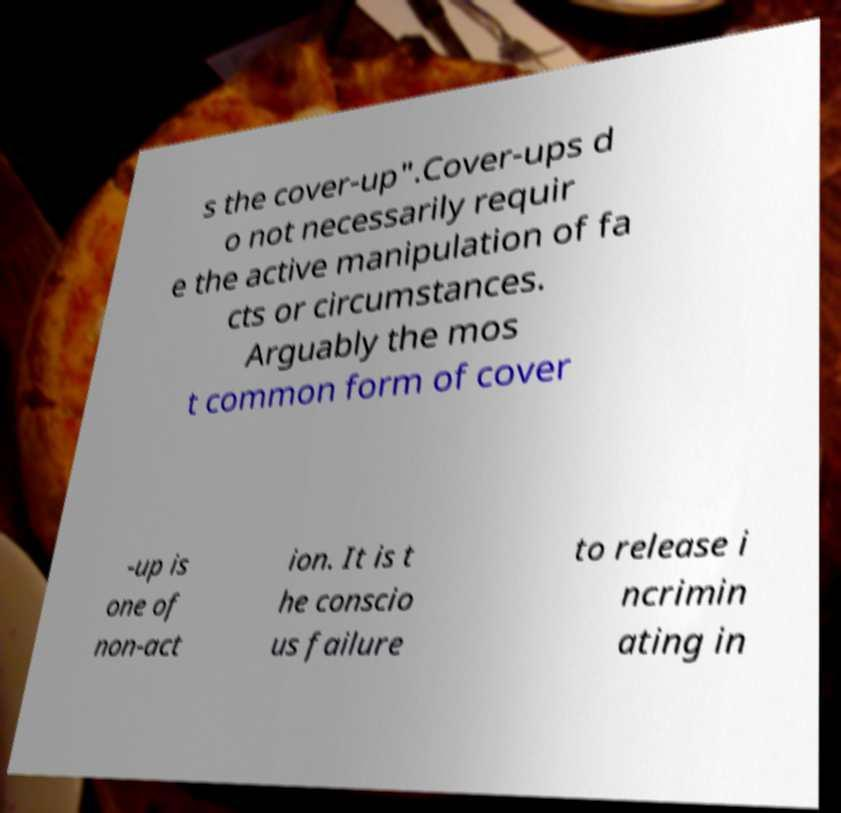Please read and relay the text visible in this image. What does it say? s the cover-up".Cover-ups d o not necessarily requir e the active manipulation of fa cts or circumstances. Arguably the mos t common form of cover -up is one of non-act ion. It is t he conscio us failure to release i ncrimin ating in 